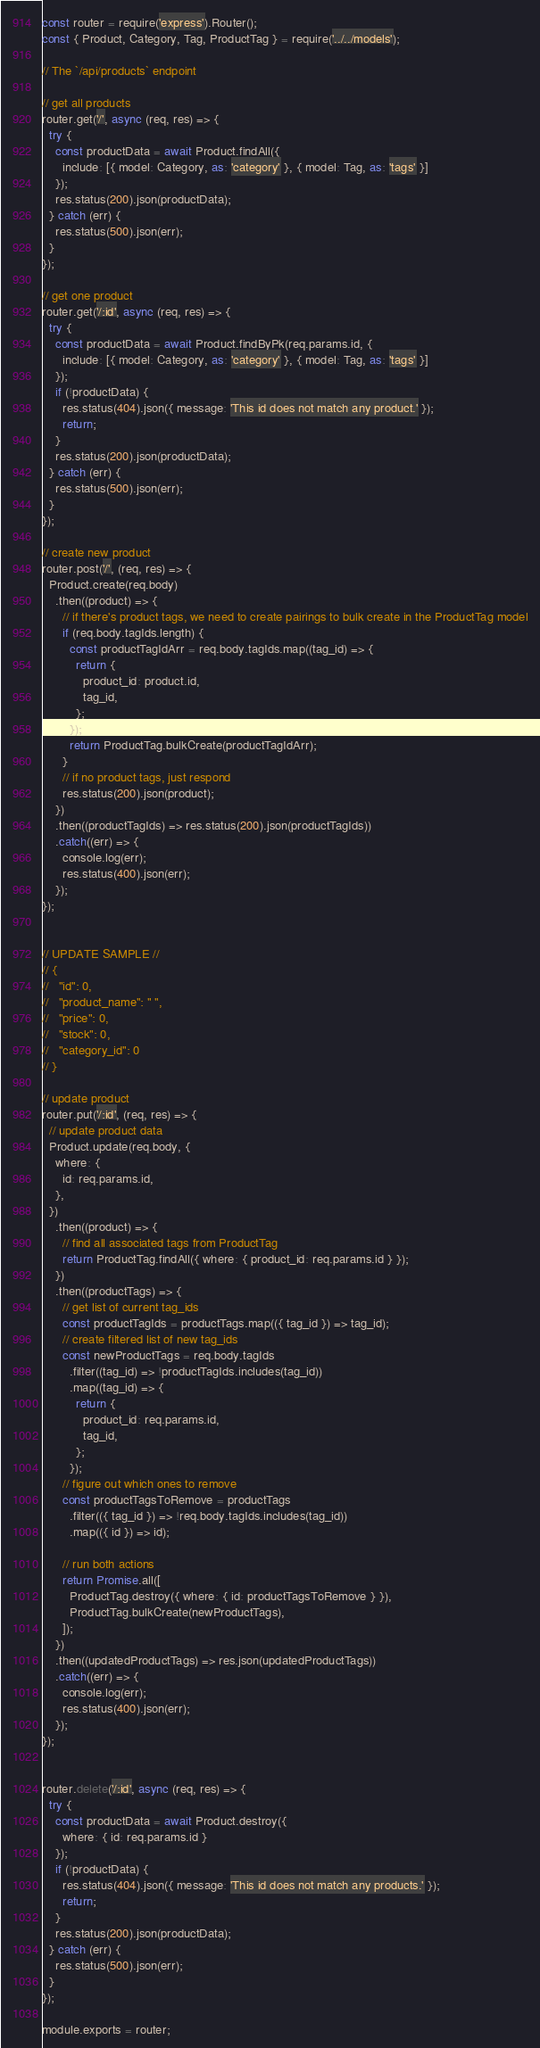<code> <loc_0><loc_0><loc_500><loc_500><_JavaScript_>const router = require('express').Router();
const { Product, Category, Tag, ProductTag } = require('../../models');

// The `/api/products` endpoint

// get all products
router.get('/', async (req, res) => {
  try {
    const productData = await Product.findAll({
      include: [{ model: Category, as: 'category' }, { model: Tag, as: 'tags' }]
    });
    res.status(200).json(productData);
  } catch (err) {
    res.status(500).json(err);
  }
});

// get one product
router.get('/:id', async (req, res) => {
  try {
    const productData = await Product.findByPk(req.params.id, {
      include: [{ model: Category, as: 'category' }, { model: Tag, as: 'tags' }]
    });
    if (!productData) {
      res.status(404).json({ message: 'This id does not match any product.' });
      return;
    }
    res.status(200).json(productData);
  } catch (err) {
    res.status(500).json(err);
  }
});

// create new product
router.post('/', (req, res) => {
  Product.create(req.body)
    .then((product) => {
      // if there's product tags, we need to create pairings to bulk create in the ProductTag model
      if (req.body.tagIds.length) {
        const productTagIdArr = req.body.tagIds.map((tag_id) => {
          return {
            product_id: product.id,
            tag_id,
          };
        });
        return ProductTag.bulkCreate(productTagIdArr);
      }
      // if no product tags, just respond
      res.status(200).json(product);
    })
    .then((productTagIds) => res.status(200).json(productTagIds))
    .catch((err) => {
      console.log(err);
      res.status(400).json(err);
    });
});


// UPDATE SAMPLE //
// {
//   "id": 0,
//   "product_name": " ",
//   "price": 0,
//   "stock": 0,
//   "category_id": 0
// }

// update product
router.put('/:id', (req, res) => {
  // update product data
  Product.update(req.body, {
    where: {
      id: req.params.id,
    },
  })
    .then((product) => {
      // find all associated tags from ProductTag
      return ProductTag.findAll({ where: { product_id: req.params.id } });
    })
    .then((productTags) => {
      // get list of current tag_ids
      const productTagIds = productTags.map(({ tag_id }) => tag_id);
      // create filtered list of new tag_ids
      const newProductTags = req.body.tagIds
        .filter((tag_id) => !productTagIds.includes(tag_id))
        .map((tag_id) => {
          return {
            product_id: req.params.id,
            tag_id,
          };
        });
      // figure out which ones to remove
      const productTagsToRemove = productTags
        .filter(({ tag_id }) => !req.body.tagIds.includes(tag_id))
        .map(({ id }) => id);

      // run both actions
      return Promise.all([
        ProductTag.destroy({ where: { id: productTagsToRemove } }),
        ProductTag.bulkCreate(newProductTags),
      ]);
    })
    .then((updatedProductTags) => res.json(updatedProductTags))
    .catch((err) => {
      console.log(err);
      res.status(400).json(err);
    });
});


router.delete('/:id', async (req, res) => {
  try {
    const productData = await Product.destroy({
      where: { id: req.params.id }
    });
    if (!productData) {
      res.status(404).json({ message: 'This id does not match any products.' });
      return;
    }
    res.status(200).json(productData);
  } catch (err) {
    res.status(500).json(err);
  }
});

module.exports = router;


</code> 